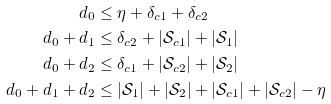<formula> <loc_0><loc_0><loc_500><loc_500>d _ { 0 } & \leq \eta + \delta _ { c 1 } + \delta _ { c 2 } \\ d _ { 0 } + d _ { 1 } & \leq \delta _ { c 2 } + | \mathcal { S } _ { c 1 } | + | \mathcal { S } _ { 1 } | \\ d _ { 0 } + d _ { 2 } & \leq \delta _ { c 1 } + | \mathcal { S } _ { c 2 } | + | \mathcal { S } _ { 2 } | \\ d _ { 0 } + d _ { 1 } + d _ { 2 } & \leq | \mathcal { S } _ { 1 } | + | \mathcal { S } _ { 2 } | + | \mathcal { S } _ { c 1 } | + | \mathcal { S } _ { c 2 } | - \eta</formula> 